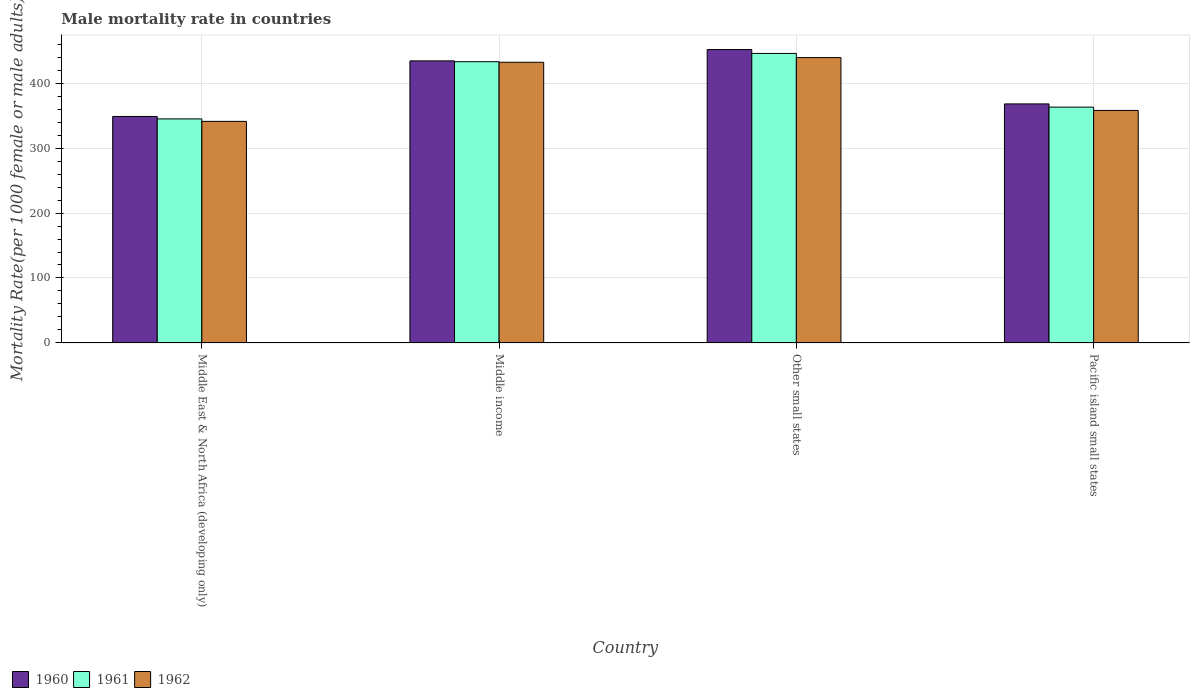How many different coloured bars are there?
Your response must be concise. 3. Are the number of bars per tick equal to the number of legend labels?
Provide a short and direct response. Yes. What is the label of the 3rd group of bars from the left?
Your answer should be very brief. Other small states. What is the male mortality rate in 1962 in Middle East & North Africa (developing only)?
Keep it short and to the point. 341.13. Across all countries, what is the maximum male mortality rate in 1960?
Provide a succinct answer. 451.71. Across all countries, what is the minimum male mortality rate in 1960?
Offer a terse response. 348.66. In which country was the male mortality rate in 1962 maximum?
Provide a short and direct response. Other small states. In which country was the male mortality rate in 1960 minimum?
Offer a very short reply. Middle East & North Africa (developing only). What is the total male mortality rate in 1960 in the graph?
Make the answer very short. 1602.61. What is the difference between the male mortality rate in 1961 in Middle East & North Africa (developing only) and that in Pacific island small states?
Your response must be concise. -18.12. What is the difference between the male mortality rate in 1961 in Middle East & North Africa (developing only) and the male mortality rate in 1960 in Other small states?
Keep it short and to the point. -106.77. What is the average male mortality rate in 1961 per country?
Keep it short and to the point. 396.68. What is the difference between the male mortality rate of/in 1961 and male mortality rate of/in 1962 in Middle income?
Your answer should be compact. 0.9. In how many countries, is the male mortality rate in 1962 greater than 100?
Your answer should be compact. 4. What is the ratio of the male mortality rate in 1961 in Other small states to that in Pacific island small states?
Provide a succinct answer. 1.23. Is the male mortality rate in 1961 in Middle East & North Africa (developing only) less than that in Other small states?
Offer a terse response. Yes. Is the difference between the male mortality rate in 1961 in Middle East & North Africa (developing only) and Pacific island small states greater than the difference between the male mortality rate in 1962 in Middle East & North Africa (developing only) and Pacific island small states?
Your response must be concise. No. What is the difference between the highest and the second highest male mortality rate in 1960?
Your answer should be very brief. -17.46. What is the difference between the highest and the lowest male mortality rate in 1961?
Ensure brevity in your answer.  100.79. In how many countries, is the male mortality rate in 1960 greater than the average male mortality rate in 1960 taken over all countries?
Provide a succinct answer. 2. Is the sum of the male mortality rate in 1961 in Middle East & North Africa (developing only) and Pacific island small states greater than the maximum male mortality rate in 1962 across all countries?
Provide a succinct answer. Yes. Is it the case that in every country, the sum of the male mortality rate in 1960 and male mortality rate in 1962 is greater than the male mortality rate in 1961?
Ensure brevity in your answer.  Yes. How many bars are there?
Your answer should be very brief. 12. Are the values on the major ticks of Y-axis written in scientific E-notation?
Make the answer very short. No. Does the graph contain any zero values?
Keep it short and to the point. No. Does the graph contain grids?
Provide a short and direct response. Yes. Where does the legend appear in the graph?
Keep it short and to the point. Bottom left. How are the legend labels stacked?
Your answer should be very brief. Horizontal. What is the title of the graph?
Offer a terse response. Male mortality rate in countries. What is the label or title of the Y-axis?
Ensure brevity in your answer.  Mortality Rate(per 1000 female or male adults). What is the Mortality Rate(per 1000 female or male adults) of 1960 in Middle East & North Africa (developing only)?
Keep it short and to the point. 348.66. What is the Mortality Rate(per 1000 female or male adults) of 1961 in Middle East & North Africa (developing only)?
Ensure brevity in your answer.  344.93. What is the Mortality Rate(per 1000 female or male adults) in 1962 in Middle East & North Africa (developing only)?
Offer a terse response. 341.13. What is the Mortality Rate(per 1000 female or male adults) in 1960 in Middle income?
Keep it short and to the point. 434.25. What is the Mortality Rate(per 1000 female or male adults) of 1961 in Middle income?
Give a very brief answer. 433. What is the Mortality Rate(per 1000 female or male adults) of 1962 in Middle income?
Make the answer very short. 432.1. What is the Mortality Rate(per 1000 female or male adults) in 1960 in Other small states?
Provide a short and direct response. 451.71. What is the Mortality Rate(per 1000 female or male adults) in 1961 in Other small states?
Your answer should be very brief. 445.72. What is the Mortality Rate(per 1000 female or male adults) in 1962 in Other small states?
Give a very brief answer. 439.31. What is the Mortality Rate(per 1000 female or male adults) of 1960 in Pacific island small states?
Provide a short and direct response. 368. What is the Mortality Rate(per 1000 female or male adults) in 1961 in Pacific island small states?
Give a very brief answer. 363.05. What is the Mortality Rate(per 1000 female or male adults) in 1962 in Pacific island small states?
Your answer should be very brief. 357.97. Across all countries, what is the maximum Mortality Rate(per 1000 female or male adults) of 1960?
Provide a succinct answer. 451.71. Across all countries, what is the maximum Mortality Rate(per 1000 female or male adults) in 1961?
Provide a short and direct response. 445.72. Across all countries, what is the maximum Mortality Rate(per 1000 female or male adults) of 1962?
Make the answer very short. 439.31. Across all countries, what is the minimum Mortality Rate(per 1000 female or male adults) of 1960?
Provide a short and direct response. 348.66. Across all countries, what is the minimum Mortality Rate(per 1000 female or male adults) in 1961?
Offer a very short reply. 344.93. Across all countries, what is the minimum Mortality Rate(per 1000 female or male adults) in 1962?
Provide a succinct answer. 341.13. What is the total Mortality Rate(per 1000 female or male adults) of 1960 in the graph?
Your response must be concise. 1602.61. What is the total Mortality Rate(per 1000 female or male adults) in 1961 in the graph?
Your answer should be very brief. 1586.7. What is the total Mortality Rate(per 1000 female or male adults) of 1962 in the graph?
Your response must be concise. 1570.51. What is the difference between the Mortality Rate(per 1000 female or male adults) in 1960 in Middle East & North Africa (developing only) and that in Middle income?
Keep it short and to the point. -85.59. What is the difference between the Mortality Rate(per 1000 female or male adults) of 1961 in Middle East & North Africa (developing only) and that in Middle income?
Offer a terse response. -88.07. What is the difference between the Mortality Rate(per 1000 female or male adults) of 1962 in Middle East & North Africa (developing only) and that in Middle income?
Offer a very short reply. -90.98. What is the difference between the Mortality Rate(per 1000 female or male adults) in 1960 in Middle East & North Africa (developing only) and that in Other small states?
Offer a very short reply. -103.05. What is the difference between the Mortality Rate(per 1000 female or male adults) in 1961 in Middle East & North Africa (developing only) and that in Other small states?
Keep it short and to the point. -100.79. What is the difference between the Mortality Rate(per 1000 female or male adults) in 1962 in Middle East & North Africa (developing only) and that in Other small states?
Your answer should be very brief. -98.18. What is the difference between the Mortality Rate(per 1000 female or male adults) in 1960 in Middle East & North Africa (developing only) and that in Pacific island small states?
Offer a very short reply. -19.34. What is the difference between the Mortality Rate(per 1000 female or male adults) of 1961 in Middle East & North Africa (developing only) and that in Pacific island small states?
Make the answer very short. -18.12. What is the difference between the Mortality Rate(per 1000 female or male adults) in 1962 in Middle East & North Africa (developing only) and that in Pacific island small states?
Ensure brevity in your answer.  -16.84. What is the difference between the Mortality Rate(per 1000 female or male adults) in 1960 in Middle income and that in Other small states?
Your response must be concise. -17.46. What is the difference between the Mortality Rate(per 1000 female or male adults) in 1961 in Middle income and that in Other small states?
Provide a short and direct response. -12.72. What is the difference between the Mortality Rate(per 1000 female or male adults) in 1962 in Middle income and that in Other small states?
Ensure brevity in your answer.  -7.21. What is the difference between the Mortality Rate(per 1000 female or male adults) of 1960 in Middle income and that in Pacific island small states?
Your response must be concise. 66.25. What is the difference between the Mortality Rate(per 1000 female or male adults) of 1961 in Middle income and that in Pacific island small states?
Your answer should be compact. 69.95. What is the difference between the Mortality Rate(per 1000 female or male adults) of 1962 in Middle income and that in Pacific island small states?
Your answer should be very brief. 74.14. What is the difference between the Mortality Rate(per 1000 female or male adults) in 1960 in Other small states and that in Pacific island small states?
Offer a very short reply. 83.71. What is the difference between the Mortality Rate(per 1000 female or male adults) of 1961 in Other small states and that in Pacific island small states?
Offer a terse response. 82.67. What is the difference between the Mortality Rate(per 1000 female or male adults) in 1962 in Other small states and that in Pacific island small states?
Your answer should be compact. 81.34. What is the difference between the Mortality Rate(per 1000 female or male adults) in 1960 in Middle East & North Africa (developing only) and the Mortality Rate(per 1000 female or male adults) in 1961 in Middle income?
Give a very brief answer. -84.34. What is the difference between the Mortality Rate(per 1000 female or male adults) of 1960 in Middle East & North Africa (developing only) and the Mortality Rate(per 1000 female or male adults) of 1962 in Middle income?
Make the answer very short. -83.45. What is the difference between the Mortality Rate(per 1000 female or male adults) of 1961 in Middle East & North Africa (developing only) and the Mortality Rate(per 1000 female or male adults) of 1962 in Middle income?
Provide a short and direct response. -87.17. What is the difference between the Mortality Rate(per 1000 female or male adults) of 1960 in Middle East & North Africa (developing only) and the Mortality Rate(per 1000 female or male adults) of 1961 in Other small states?
Offer a very short reply. -97.06. What is the difference between the Mortality Rate(per 1000 female or male adults) in 1960 in Middle East & North Africa (developing only) and the Mortality Rate(per 1000 female or male adults) in 1962 in Other small states?
Provide a short and direct response. -90.65. What is the difference between the Mortality Rate(per 1000 female or male adults) in 1961 in Middle East & North Africa (developing only) and the Mortality Rate(per 1000 female or male adults) in 1962 in Other small states?
Give a very brief answer. -94.38. What is the difference between the Mortality Rate(per 1000 female or male adults) of 1960 in Middle East & North Africa (developing only) and the Mortality Rate(per 1000 female or male adults) of 1961 in Pacific island small states?
Your answer should be very brief. -14.39. What is the difference between the Mortality Rate(per 1000 female or male adults) in 1960 in Middle East & North Africa (developing only) and the Mortality Rate(per 1000 female or male adults) in 1962 in Pacific island small states?
Your response must be concise. -9.31. What is the difference between the Mortality Rate(per 1000 female or male adults) in 1961 in Middle East & North Africa (developing only) and the Mortality Rate(per 1000 female or male adults) in 1962 in Pacific island small states?
Your response must be concise. -13.04. What is the difference between the Mortality Rate(per 1000 female or male adults) in 1960 in Middle income and the Mortality Rate(per 1000 female or male adults) in 1961 in Other small states?
Your answer should be compact. -11.47. What is the difference between the Mortality Rate(per 1000 female or male adults) of 1960 in Middle income and the Mortality Rate(per 1000 female or male adults) of 1962 in Other small states?
Keep it short and to the point. -5.06. What is the difference between the Mortality Rate(per 1000 female or male adults) in 1961 in Middle income and the Mortality Rate(per 1000 female or male adults) in 1962 in Other small states?
Your response must be concise. -6.31. What is the difference between the Mortality Rate(per 1000 female or male adults) of 1960 in Middle income and the Mortality Rate(per 1000 female or male adults) of 1961 in Pacific island small states?
Keep it short and to the point. 71.2. What is the difference between the Mortality Rate(per 1000 female or male adults) of 1960 in Middle income and the Mortality Rate(per 1000 female or male adults) of 1962 in Pacific island small states?
Offer a very short reply. 76.28. What is the difference between the Mortality Rate(per 1000 female or male adults) of 1961 in Middle income and the Mortality Rate(per 1000 female or male adults) of 1962 in Pacific island small states?
Your answer should be very brief. 75.03. What is the difference between the Mortality Rate(per 1000 female or male adults) in 1960 in Other small states and the Mortality Rate(per 1000 female or male adults) in 1961 in Pacific island small states?
Give a very brief answer. 88.65. What is the difference between the Mortality Rate(per 1000 female or male adults) in 1960 in Other small states and the Mortality Rate(per 1000 female or male adults) in 1962 in Pacific island small states?
Keep it short and to the point. 93.74. What is the difference between the Mortality Rate(per 1000 female or male adults) in 1961 in Other small states and the Mortality Rate(per 1000 female or male adults) in 1962 in Pacific island small states?
Provide a succinct answer. 87.75. What is the average Mortality Rate(per 1000 female or male adults) of 1960 per country?
Provide a succinct answer. 400.65. What is the average Mortality Rate(per 1000 female or male adults) of 1961 per country?
Ensure brevity in your answer.  396.68. What is the average Mortality Rate(per 1000 female or male adults) in 1962 per country?
Keep it short and to the point. 392.63. What is the difference between the Mortality Rate(per 1000 female or male adults) in 1960 and Mortality Rate(per 1000 female or male adults) in 1961 in Middle East & North Africa (developing only)?
Ensure brevity in your answer.  3.73. What is the difference between the Mortality Rate(per 1000 female or male adults) of 1960 and Mortality Rate(per 1000 female or male adults) of 1962 in Middle East & North Africa (developing only)?
Offer a very short reply. 7.53. What is the difference between the Mortality Rate(per 1000 female or male adults) of 1961 and Mortality Rate(per 1000 female or male adults) of 1962 in Middle East & North Africa (developing only)?
Provide a succinct answer. 3.8. What is the difference between the Mortality Rate(per 1000 female or male adults) in 1960 and Mortality Rate(per 1000 female or male adults) in 1961 in Middle income?
Give a very brief answer. 1.25. What is the difference between the Mortality Rate(per 1000 female or male adults) of 1960 and Mortality Rate(per 1000 female or male adults) of 1962 in Middle income?
Your answer should be compact. 2.14. What is the difference between the Mortality Rate(per 1000 female or male adults) in 1961 and Mortality Rate(per 1000 female or male adults) in 1962 in Middle income?
Your answer should be compact. 0.9. What is the difference between the Mortality Rate(per 1000 female or male adults) in 1960 and Mortality Rate(per 1000 female or male adults) in 1961 in Other small states?
Make the answer very short. 5.99. What is the difference between the Mortality Rate(per 1000 female or male adults) in 1960 and Mortality Rate(per 1000 female or male adults) in 1962 in Other small states?
Offer a terse response. 12.39. What is the difference between the Mortality Rate(per 1000 female or male adults) of 1961 and Mortality Rate(per 1000 female or male adults) of 1962 in Other small states?
Offer a very short reply. 6.41. What is the difference between the Mortality Rate(per 1000 female or male adults) in 1960 and Mortality Rate(per 1000 female or male adults) in 1961 in Pacific island small states?
Make the answer very short. 4.95. What is the difference between the Mortality Rate(per 1000 female or male adults) of 1960 and Mortality Rate(per 1000 female or male adults) of 1962 in Pacific island small states?
Give a very brief answer. 10.03. What is the difference between the Mortality Rate(per 1000 female or male adults) of 1961 and Mortality Rate(per 1000 female or male adults) of 1962 in Pacific island small states?
Offer a terse response. 5.08. What is the ratio of the Mortality Rate(per 1000 female or male adults) in 1960 in Middle East & North Africa (developing only) to that in Middle income?
Offer a very short reply. 0.8. What is the ratio of the Mortality Rate(per 1000 female or male adults) of 1961 in Middle East & North Africa (developing only) to that in Middle income?
Ensure brevity in your answer.  0.8. What is the ratio of the Mortality Rate(per 1000 female or male adults) in 1962 in Middle East & North Africa (developing only) to that in Middle income?
Offer a terse response. 0.79. What is the ratio of the Mortality Rate(per 1000 female or male adults) in 1960 in Middle East & North Africa (developing only) to that in Other small states?
Ensure brevity in your answer.  0.77. What is the ratio of the Mortality Rate(per 1000 female or male adults) in 1961 in Middle East & North Africa (developing only) to that in Other small states?
Your answer should be very brief. 0.77. What is the ratio of the Mortality Rate(per 1000 female or male adults) of 1962 in Middle East & North Africa (developing only) to that in Other small states?
Provide a short and direct response. 0.78. What is the ratio of the Mortality Rate(per 1000 female or male adults) in 1961 in Middle East & North Africa (developing only) to that in Pacific island small states?
Offer a terse response. 0.95. What is the ratio of the Mortality Rate(per 1000 female or male adults) of 1962 in Middle East & North Africa (developing only) to that in Pacific island small states?
Keep it short and to the point. 0.95. What is the ratio of the Mortality Rate(per 1000 female or male adults) in 1960 in Middle income to that in Other small states?
Offer a very short reply. 0.96. What is the ratio of the Mortality Rate(per 1000 female or male adults) in 1961 in Middle income to that in Other small states?
Offer a very short reply. 0.97. What is the ratio of the Mortality Rate(per 1000 female or male adults) of 1962 in Middle income to that in Other small states?
Your response must be concise. 0.98. What is the ratio of the Mortality Rate(per 1000 female or male adults) of 1960 in Middle income to that in Pacific island small states?
Your response must be concise. 1.18. What is the ratio of the Mortality Rate(per 1000 female or male adults) in 1961 in Middle income to that in Pacific island small states?
Your answer should be compact. 1.19. What is the ratio of the Mortality Rate(per 1000 female or male adults) of 1962 in Middle income to that in Pacific island small states?
Make the answer very short. 1.21. What is the ratio of the Mortality Rate(per 1000 female or male adults) in 1960 in Other small states to that in Pacific island small states?
Keep it short and to the point. 1.23. What is the ratio of the Mortality Rate(per 1000 female or male adults) in 1961 in Other small states to that in Pacific island small states?
Offer a terse response. 1.23. What is the ratio of the Mortality Rate(per 1000 female or male adults) of 1962 in Other small states to that in Pacific island small states?
Provide a short and direct response. 1.23. What is the difference between the highest and the second highest Mortality Rate(per 1000 female or male adults) in 1960?
Your answer should be very brief. 17.46. What is the difference between the highest and the second highest Mortality Rate(per 1000 female or male adults) of 1961?
Offer a terse response. 12.72. What is the difference between the highest and the second highest Mortality Rate(per 1000 female or male adults) in 1962?
Your answer should be compact. 7.21. What is the difference between the highest and the lowest Mortality Rate(per 1000 female or male adults) of 1960?
Offer a terse response. 103.05. What is the difference between the highest and the lowest Mortality Rate(per 1000 female or male adults) of 1961?
Make the answer very short. 100.79. What is the difference between the highest and the lowest Mortality Rate(per 1000 female or male adults) of 1962?
Provide a short and direct response. 98.18. 